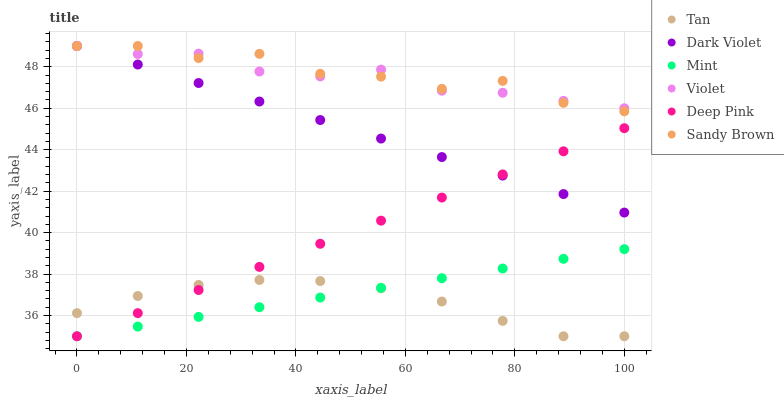Does Tan have the minimum area under the curve?
Answer yes or no. Yes. Does Sandy Brown have the maximum area under the curve?
Answer yes or no. Yes. Does Mint have the minimum area under the curve?
Answer yes or no. No. Does Mint have the maximum area under the curve?
Answer yes or no. No. Is Mint the smoothest?
Answer yes or no. Yes. Is Sandy Brown the roughest?
Answer yes or no. Yes. Is Dark Violet the smoothest?
Answer yes or no. No. Is Dark Violet the roughest?
Answer yes or no. No. Does Deep Pink have the lowest value?
Answer yes or no. Yes. Does Dark Violet have the lowest value?
Answer yes or no. No. Does Sandy Brown have the highest value?
Answer yes or no. Yes. Does Mint have the highest value?
Answer yes or no. No. Is Tan less than Dark Violet?
Answer yes or no. Yes. Is Violet greater than Tan?
Answer yes or no. Yes. Does Tan intersect Deep Pink?
Answer yes or no. Yes. Is Tan less than Deep Pink?
Answer yes or no. No. Is Tan greater than Deep Pink?
Answer yes or no. No. Does Tan intersect Dark Violet?
Answer yes or no. No. 